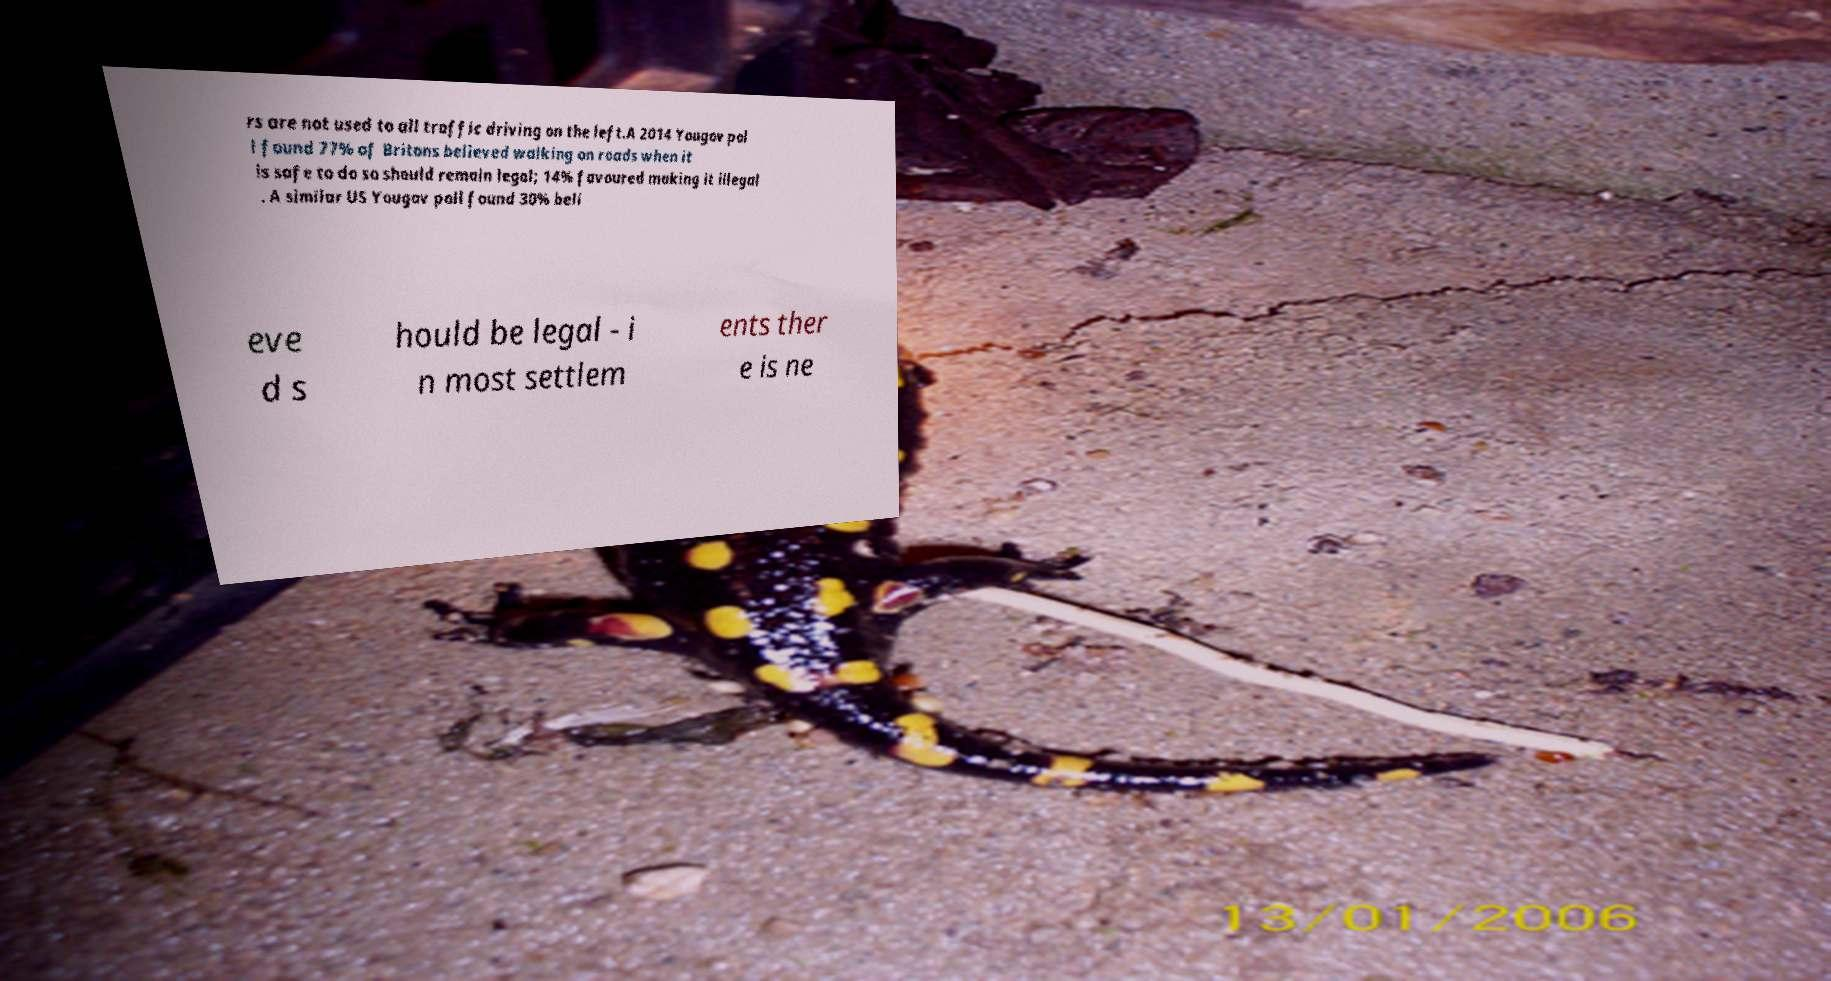Can you accurately transcribe the text from the provided image for me? rs are not used to all traffic driving on the left.A 2014 Yougov pol l found 77% of Britons believed walking on roads when it is safe to do so should remain legal; 14% favoured making it illegal . A similar US Yougov poll found 30% beli eve d s hould be legal - i n most settlem ents ther e is ne 